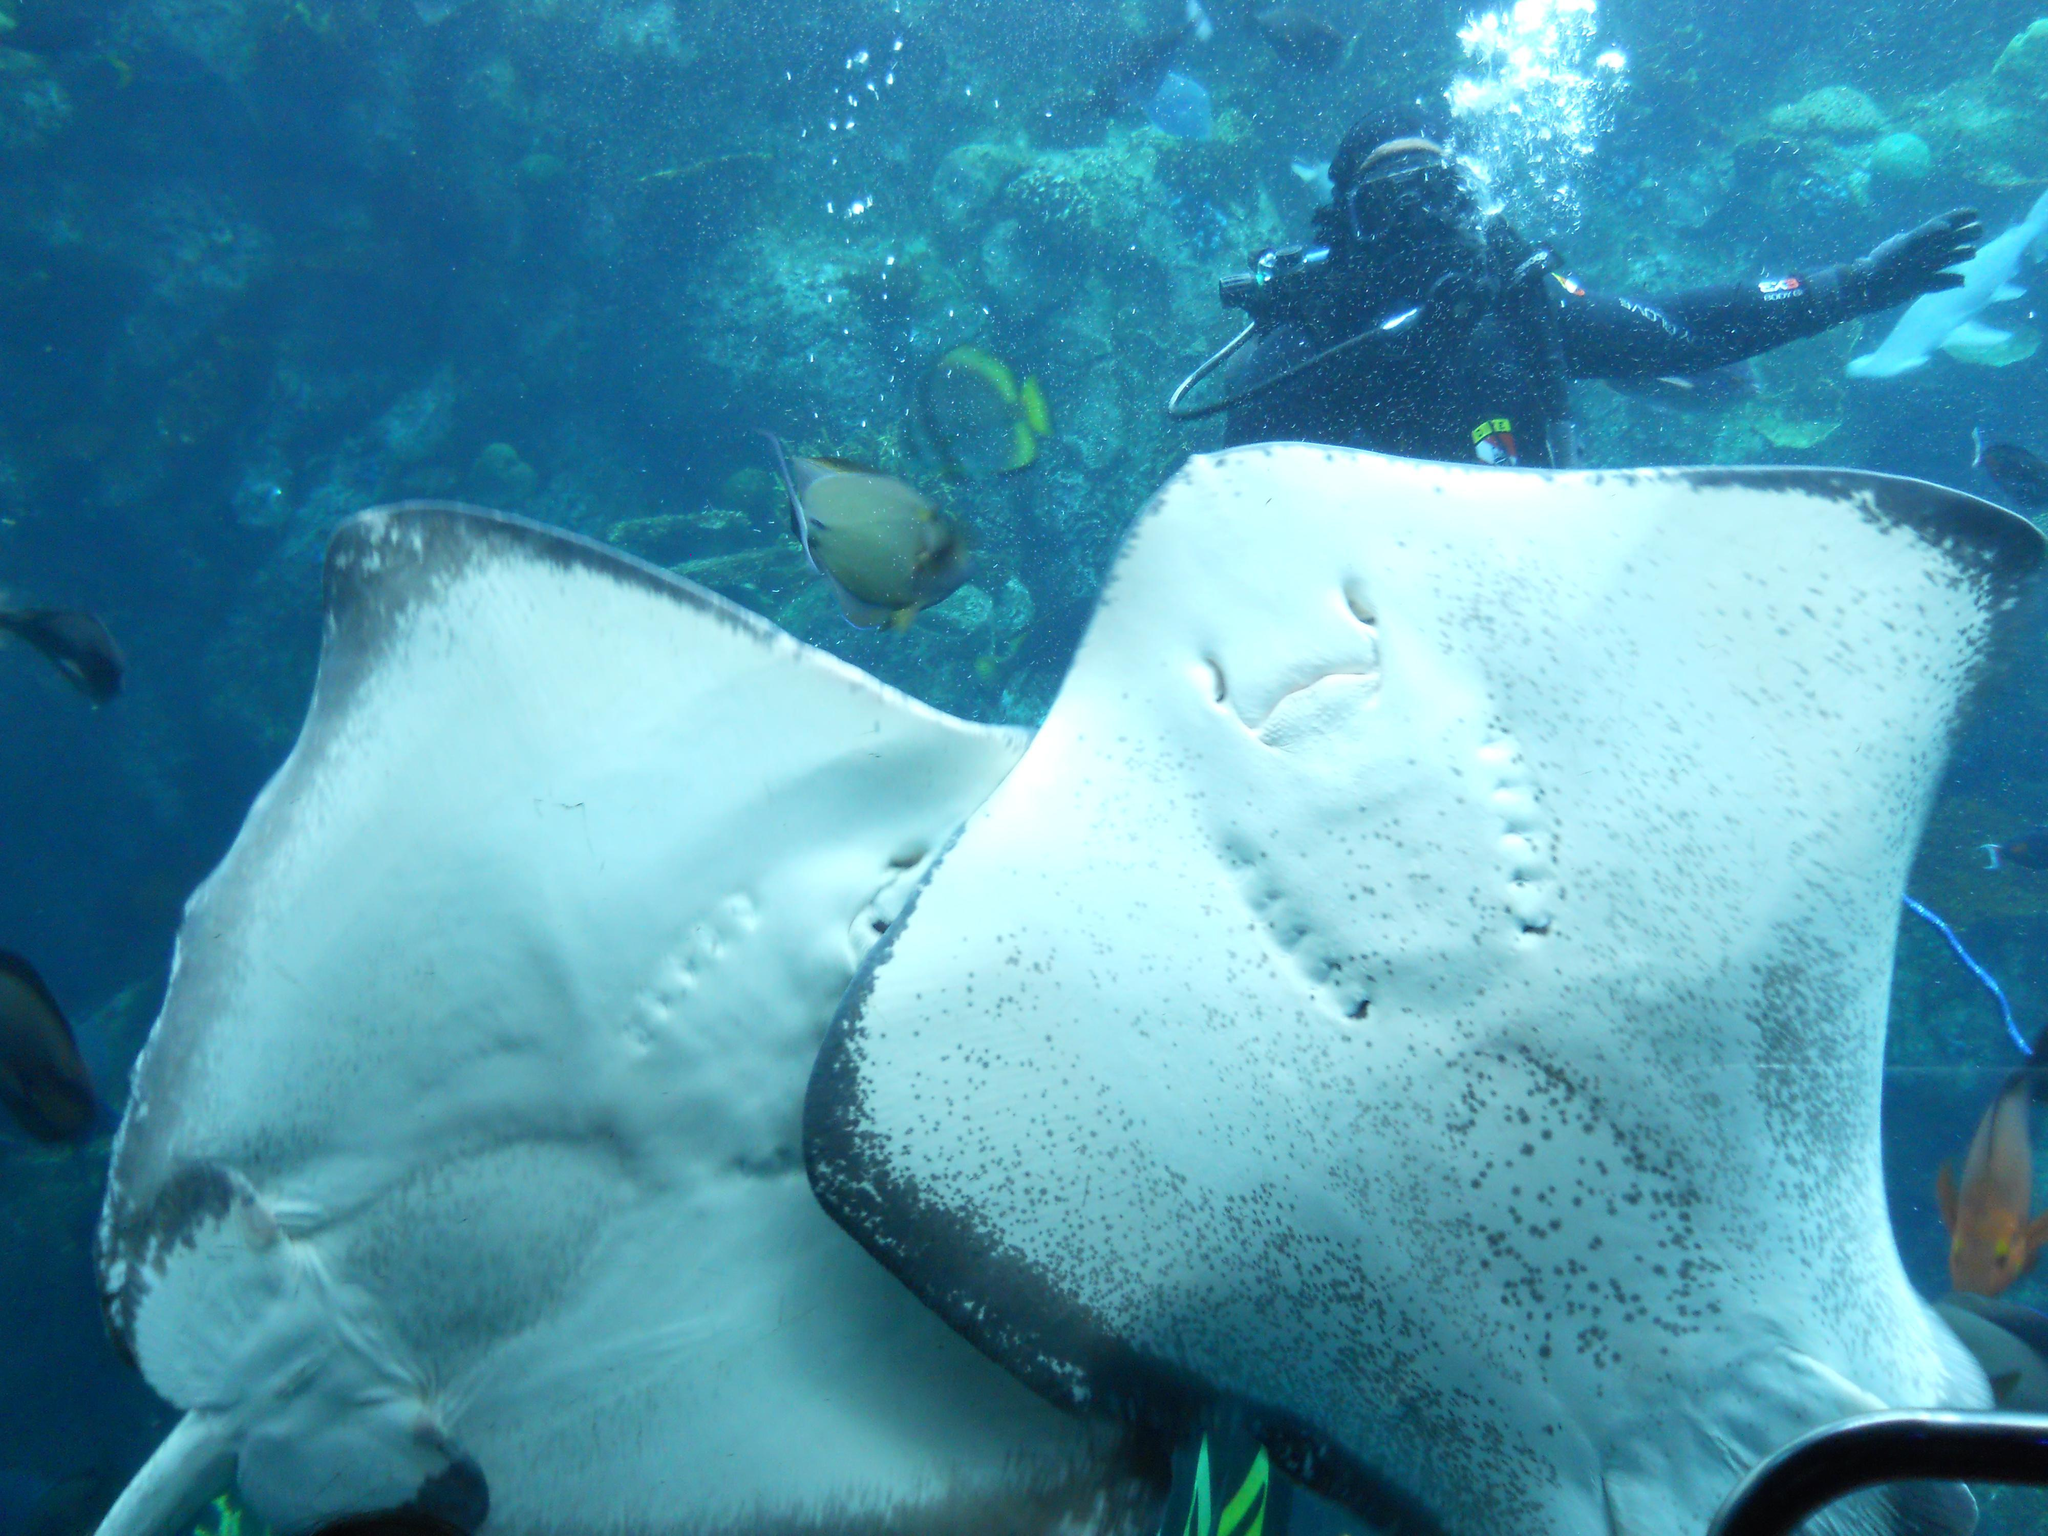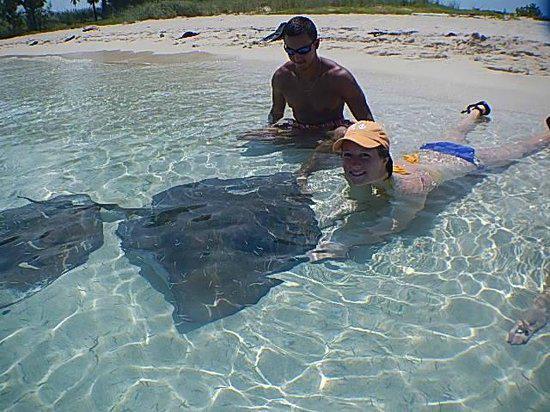The first image is the image on the left, the second image is the image on the right. For the images displayed, is the sentence "A person whose head and chest are above water is behind a stingray in the ocean." factually correct? Answer yes or no. Yes. The first image is the image on the left, the second image is the image on the right. Analyze the images presented: Is the assertion "An image contains a human touching a sting ray." valid? Answer yes or no. Yes. 